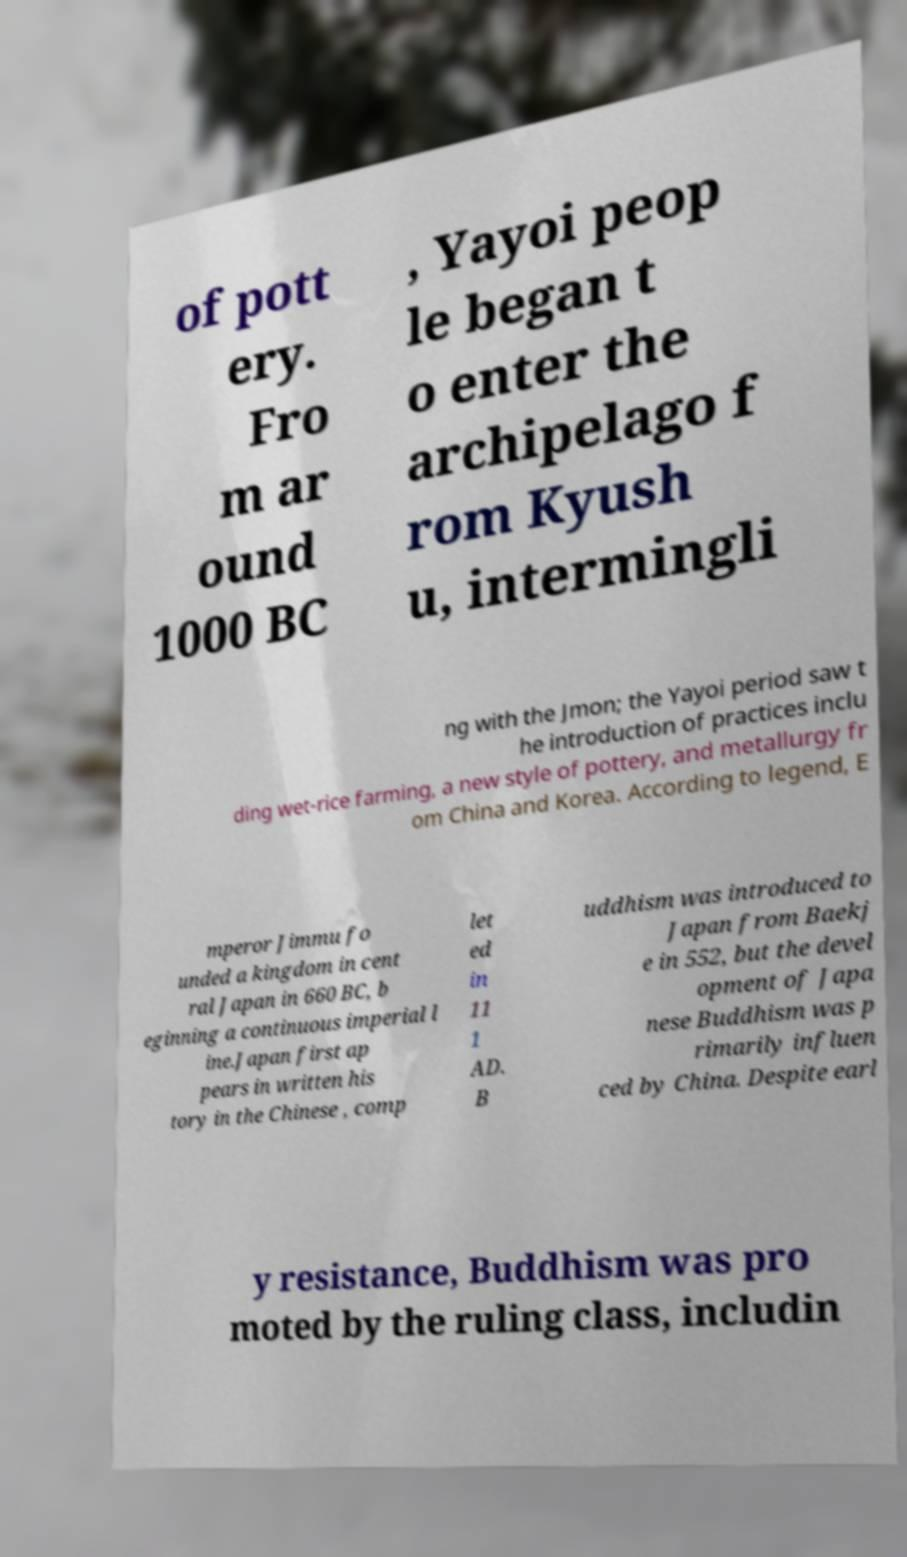For documentation purposes, I need the text within this image transcribed. Could you provide that? of pott ery. Fro m ar ound 1000 BC , Yayoi peop le began t o enter the archipelago f rom Kyush u, intermingli ng with the Jmon; the Yayoi period saw t he introduction of practices inclu ding wet-rice farming, a new style of pottery, and metallurgy fr om China and Korea. According to legend, E mperor Jimmu fo unded a kingdom in cent ral Japan in 660 BC, b eginning a continuous imperial l ine.Japan first ap pears in written his tory in the Chinese , comp let ed in 11 1 AD. B uddhism was introduced to Japan from Baekj e in 552, but the devel opment of Japa nese Buddhism was p rimarily influen ced by China. Despite earl y resistance, Buddhism was pro moted by the ruling class, includin 